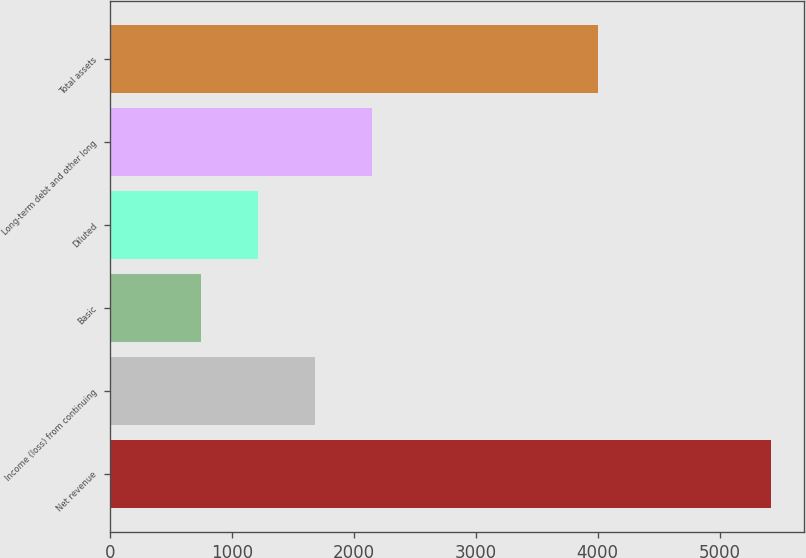Convert chart. <chart><loc_0><loc_0><loc_500><loc_500><bar_chart><fcel>Net revenue<fcel>Income (loss) from continuing<fcel>Basic<fcel>Diluted<fcel>Long-term debt and other long<fcel>Total assets<nl><fcel>5422<fcel>1677.2<fcel>741<fcel>1209.1<fcel>2145.3<fcel>4000<nl></chart> 